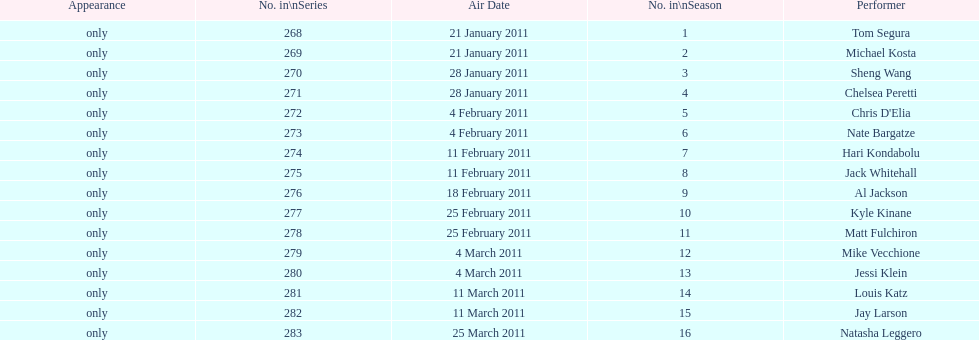Who appeared first tom segura or jay larson? Tom Segura. Could you parse the entire table as a dict? {'header': ['Appearance', 'No. in\\nSeries', 'Air Date', 'No. in\\nSeason', 'Performer'], 'rows': [['only', '268', '21 January 2011', '1', 'Tom Segura'], ['only', '269', '21 January 2011', '2', 'Michael Kosta'], ['only', '270', '28 January 2011', '3', 'Sheng Wang'], ['only', '271', '28 January 2011', '4', 'Chelsea Peretti'], ['only', '272', '4 February 2011', '5', "Chris D'Elia"], ['only', '273', '4 February 2011', '6', 'Nate Bargatze'], ['only', '274', '11 February 2011', '7', 'Hari Kondabolu'], ['only', '275', '11 February 2011', '8', 'Jack Whitehall'], ['only', '276', '18 February 2011', '9', 'Al Jackson'], ['only', '277', '25 February 2011', '10', 'Kyle Kinane'], ['only', '278', '25 February 2011', '11', 'Matt Fulchiron'], ['only', '279', '4 March 2011', '12', 'Mike Vecchione'], ['only', '280', '4 March 2011', '13', 'Jessi Klein'], ['only', '281', '11 March 2011', '14', 'Louis Katz'], ['only', '282', '11 March 2011', '15', 'Jay Larson'], ['only', '283', '25 March 2011', '16', 'Natasha Leggero']]} 